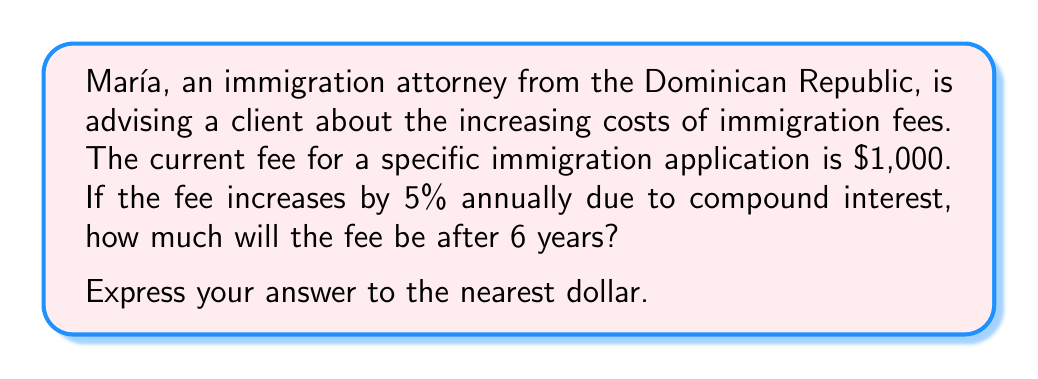Could you help me with this problem? To solve this problem, we'll use the compound interest formula:

$$ A = P(1 + r)^n $$

Where:
$A$ = Final amount
$P$ = Principal (initial amount)
$r$ = Annual interest rate (in decimal form)
$n$ = Number of years

Given:
$P = \$1,000$
$r = 5\% = 0.05$
$n = 6$ years

Let's substitute these values into the formula:

$$ A = 1000(1 + 0.05)^6 $$

Now, let's calculate step by step:

1) First, calculate $(1 + 0.05)^6$:
   $$ (1.05)^6 = 1.3401... $$

2) Multiply this result by the principal:
   $$ 1000 \times 1.3401... = 1340.10... $$

3) Round to the nearest dollar:
   $$ 1340.10... \approx \$1,340 $$

Therefore, after 6 years, the immigration fee will be approximately $1,340.
Answer: $1,340 